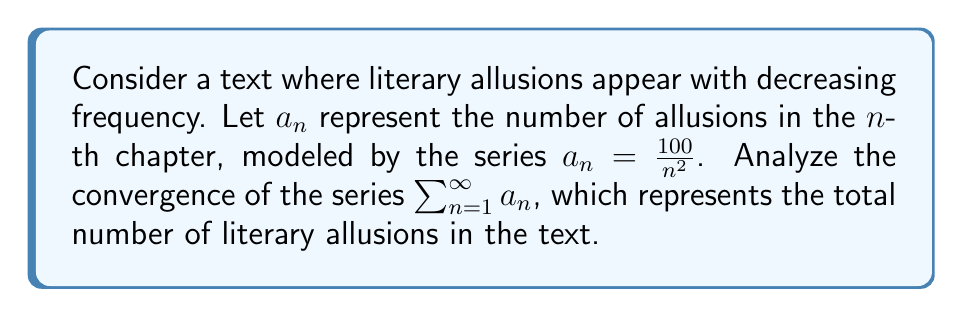What is the answer to this math problem? To analyze the convergence of this series, we can use the p-series test:

1) The general form of a p-series is $\sum_{n=1}^{\infty} \frac{1}{n^p}$

2) Our series can be rewritten as:
   $$\sum_{n=1}^{\infty} a_n = \sum_{n=1}^{\infty} \frac{100}{n^2} = 100 \sum_{n=1}^{\infty} \frac{1}{n^2}$$

3) This is a p-series with $p = 2$

4) For a p-series:
   - If $p > 1$, the series converges
   - If $p \leq 1$, the series diverges

5) In our case, $p = 2 > 1$

6) Therefore, the series converges

7) In fact, this particular series converges to a known value:
   $$\sum_{n=1}^{\infty} \frac{1}{n^2} = \frac{\pi^2}{6}$$

8) So, our series converges to:
   $$100 \cdot \frac{\pi^2}{6} = \frac{100\pi^2}{6}$$

This result suggests that while the number of allusions decreases in each chapter, the total number of allusions in the entire text is finite, emphasizing the author's judicious use of literary references.
Answer: The series converges to $\frac{100\pi^2}{6}$. 